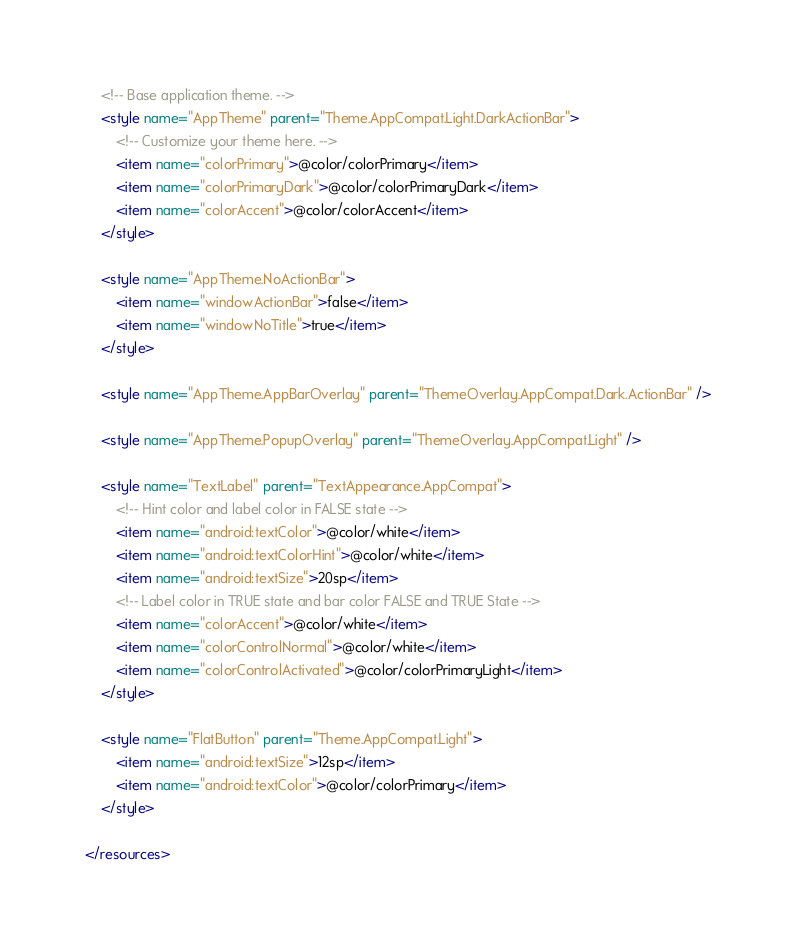Convert code to text. <code><loc_0><loc_0><loc_500><loc_500><_XML_>    <!-- Base application theme. -->
    <style name="AppTheme" parent="Theme.AppCompat.Light.DarkActionBar">
        <!-- Customize your theme here. -->
        <item name="colorPrimary">@color/colorPrimary</item>
        <item name="colorPrimaryDark">@color/colorPrimaryDark</item>
        <item name="colorAccent">@color/colorAccent</item>
    </style>

    <style name="AppTheme.NoActionBar">
        <item name="windowActionBar">false</item>
        <item name="windowNoTitle">true</item>
    </style>

    <style name="AppTheme.AppBarOverlay" parent="ThemeOverlay.AppCompat.Dark.ActionBar" />

    <style name="AppTheme.PopupOverlay" parent="ThemeOverlay.AppCompat.Light" />

    <style name="TextLabel" parent="TextAppearance.AppCompat">
        <!-- Hint color and label color in FALSE state -->
        <item name="android:textColor">@color/white</item>
        <item name="android:textColorHint">@color/white</item>
        <item name="android:textSize">20sp</item>
        <!-- Label color in TRUE state and bar color FALSE and TRUE State -->
        <item name="colorAccent">@color/white</item>
        <item name="colorControlNormal">@color/white</item>
        <item name="colorControlActivated">@color/colorPrimaryLight</item>
    </style>

    <style name="FlatButton" parent="Theme.AppCompat.Light">
        <item name="android:textSize">12sp</item>
        <item name="android:textColor">@color/colorPrimary</item>
    </style>

</resources>
</code> 